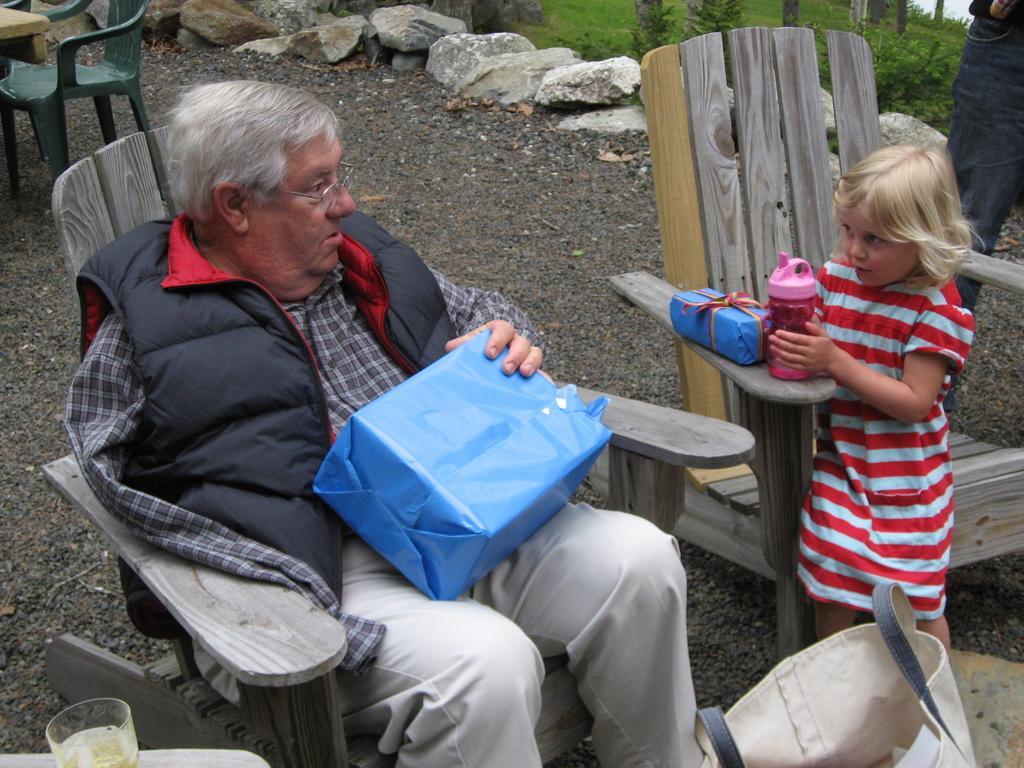How would you summarize this image in a sentence or two? In the image there is an old man sitting on wooden chair holding a box, beside him there is a girl in red and white striped dress sitting on chair on the mud floor and behind there are rocks in front of grassland. 